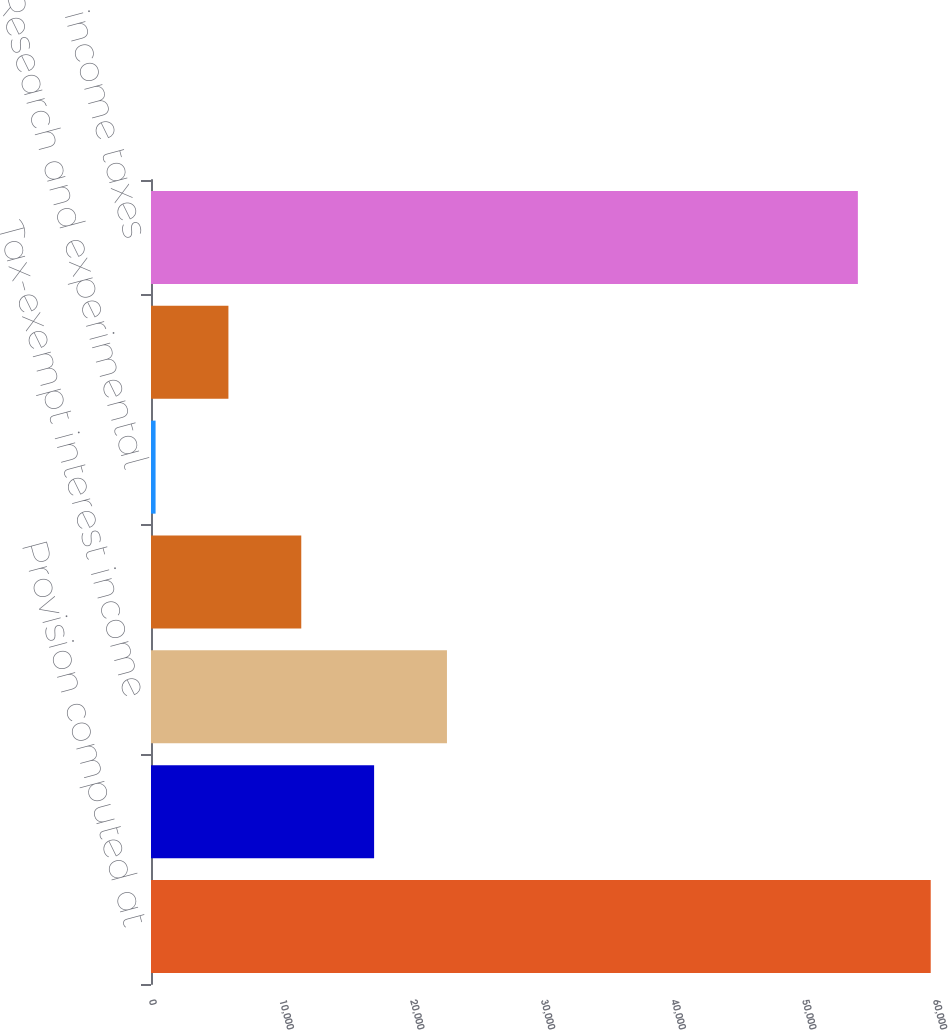Convert chart. <chart><loc_0><loc_0><loc_500><loc_500><bar_chart><fcel>Provision computed at<fcel>State income tax (net of<fcel>Tax-exempt interest income<fcel>Tax benefit of exempt foreign<fcel>Research and experimental<fcel>Other<fcel>Provision for income taxes<nl><fcel>59672.9<fcel>17074.7<fcel>22649.6<fcel>11499.8<fcel>350<fcel>5924.9<fcel>54098<nl></chart> 